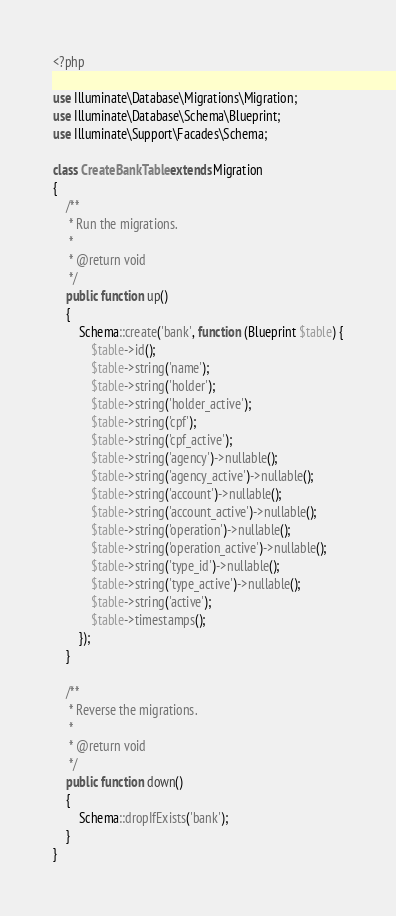Convert code to text. <code><loc_0><loc_0><loc_500><loc_500><_PHP_><?php

use Illuminate\Database\Migrations\Migration;
use Illuminate\Database\Schema\Blueprint;
use Illuminate\Support\Facades\Schema;

class CreateBankTable extends Migration
{
    /**
     * Run the migrations.
     *
     * @return void
     */
    public function up()
    {
        Schema::create('bank', function (Blueprint $table) {
            $table->id();
            $table->string('name');
            $table->string('holder');
            $table->string('holder_active');
            $table->string('cpf');
            $table->string('cpf_active');
            $table->string('agency')->nullable();
            $table->string('agency_active')->nullable();
            $table->string('account')->nullable();
            $table->string('account_active')->nullable();
            $table->string('operation')->nullable();
            $table->string('operation_active')->nullable();
            $table->string('type_id')->nullable();
            $table->string('type_active')->nullable();
            $table->string('active');
            $table->timestamps();
        });
    }

    /**
     * Reverse the migrations.
     *
     * @return void
     */
    public function down()
    {
        Schema::dropIfExists('bank');
    }
}
</code> 